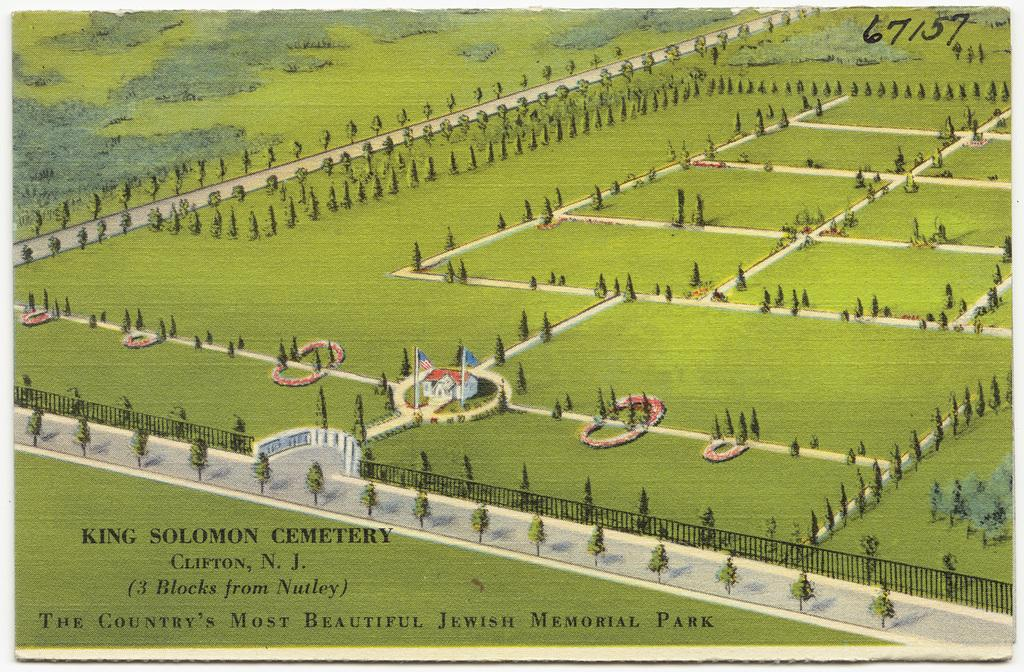<image>
Write a terse but informative summary of the picture. A postcard for King Solomon Cemetery features many trees. 